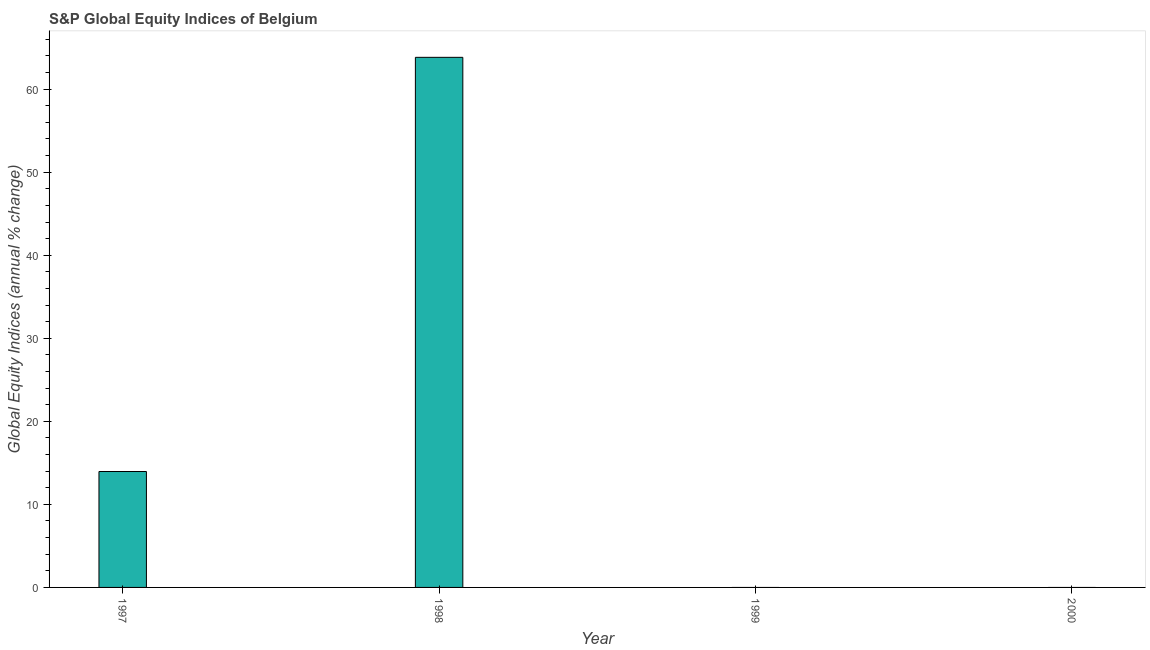Does the graph contain any zero values?
Ensure brevity in your answer.  Yes. Does the graph contain grids?
Ensure brevity in your answer.  No. What is the title of the graph?
Give a very brief answer. S&P Global Equity Indices of Belgium. What is the label or title of the Y-axis?
Offer a very short reply. Global Equity Indices (annual % change). What is the s&p global equity indices in 1999?
Ensure brevity in your answer.  0. Across all years, what is the maximum s&p global equity indices?
Offer a very short reply. 63.83. Across all years, what is the minimum s&p global equity indices?
Make the answer very short. 0. In which year was the s&p global equity indices maximum?
Give a very brief answer. 1998. What is the sum of the s&p global equity indices?
Offer a very short reply. 77.79. What is the difference between the s&p global equity indices in 1997 and 1998?
Provide a succinct answer. -49.88. What is the average s&p global equity indices per year?
Your response must be concise. 19.45. What is the median s&p global equity indices?
Your answer should be very brief. 6.98. What is the ratio of the s&p global equity indices in 1997 to that in 1998?
Make the answer very short. 0.22. What is the difference between the highest and the lowest s&p global equity indices?
Provide a short and direct response. 63.83. How many bars are there?
Offer a terse response. 2. How many years are there in the graph?
Provide a succinct answer. 4. What is the Global Equity Indices (annual % change) in 1997?
Your answer should be very brief. 13.96. What is the Global Equity Indices (annual % change) in 1998?
Offer a terse response. 63.83. What is the difference between the Global Equity Indices (annual % change) in 1997 and 1998?
Give a very brief answer. -49.87. What is the ratio of the Global Equity Indices (annual % change) in 1997 to that in 1998?
Give a very brief answer. 0.22. 